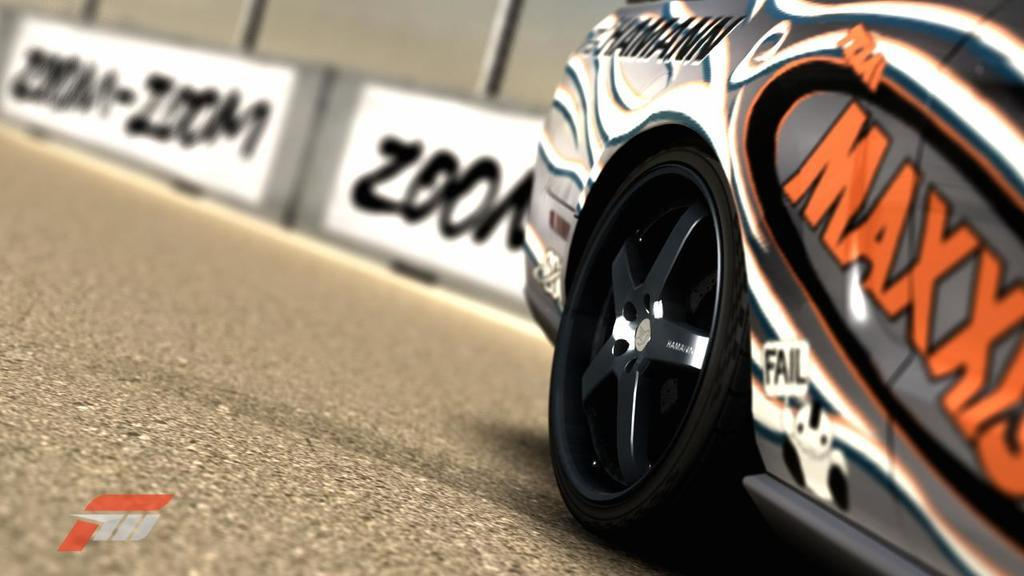What vehicle is located on the right side of the image? There is a car on the right side of the image. What objects are in the middle of the image? Boards are present in the middle of the image. What can be seen at the bottom of the image? The ground is visible at the bottom of the image. Can you tell me what the car is talking about with the bubble in the image? There is no car, bubble, or talking depicted in the image. The image only shows a car and boards on the ground. 